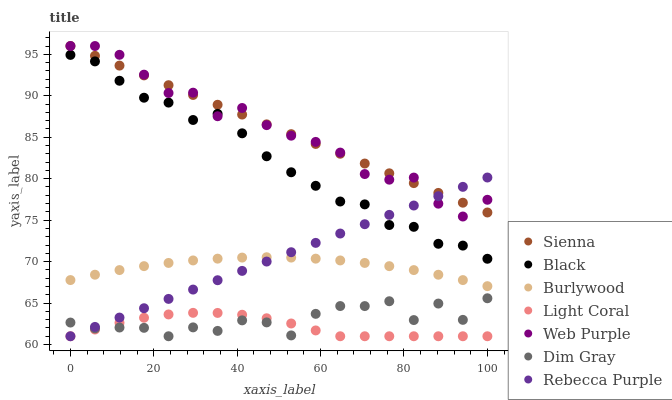Does Light Coral have the minimum area under the curve?
Answer yes or no. Yes. Does Sienna have the maximum area under the curve?
Answer yes or no. Yes. Does Dim Gray have the minimum area under the curve?
Answer yes or no. No. Does Dim Gray have the maximum area under the curve?
Answer yes or no. No. Is Rebecca Purple the smoothest?
Answer yes or no. Yes. Is Dim Gray the roughest?
Answer yes or no. Yes. Is Burlywood the smoothest?
Answer yes or no. No. Is Burlywood the roughest?
Answer yes or no. No. Does Light Coral have the lowest value?
Answer yes or no. Yes. Does Burlywood have the lowest value?
Answer yes or no. No. Does Web Purple have the highest value?
Answer yes or no. Yes. Does Dim Gray have the highest value?
Answer yes or no. No. Is Dim Gray less than Sienna?
Answer yes or no. Yes. Is Burlywood greater than Light Coral?
Answer yes or no. Yes. Does Black intersect Rebecca Purple?
Answer yes or no. Yes. Is Black less than Rebecca Purple?
Answer yes or no. No. Is Black greater than Rebecca Purple?
Answer yes or no. No. Does Dim Gray intersect Sienna?
Answer yes or no. No. 